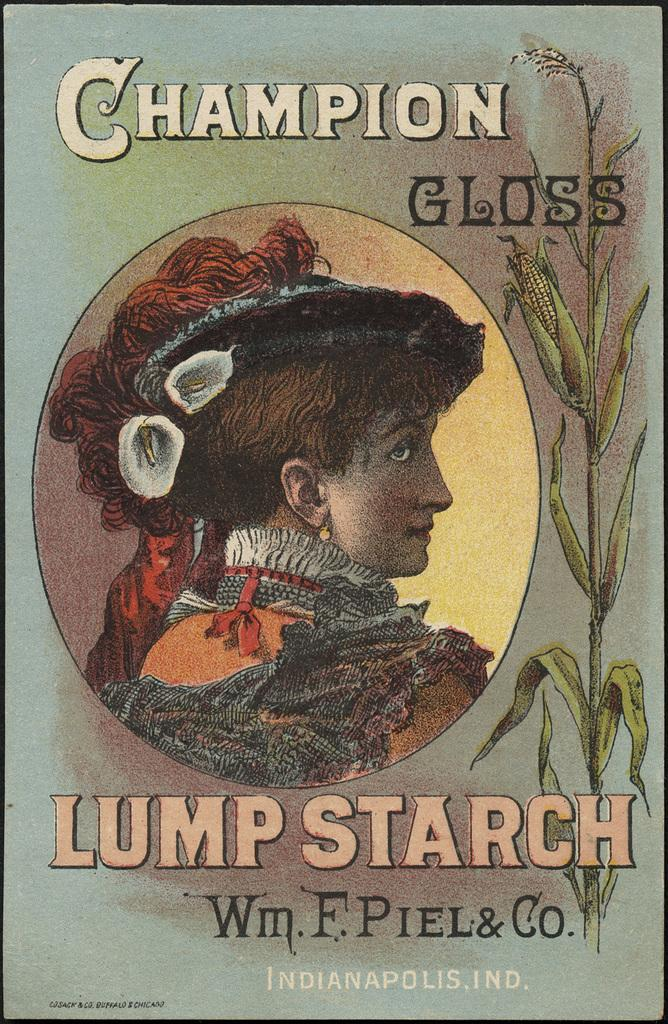<image>
Create a compact narrative representing the image presented. A poster for Champion Gloss features the side view of a woman. 